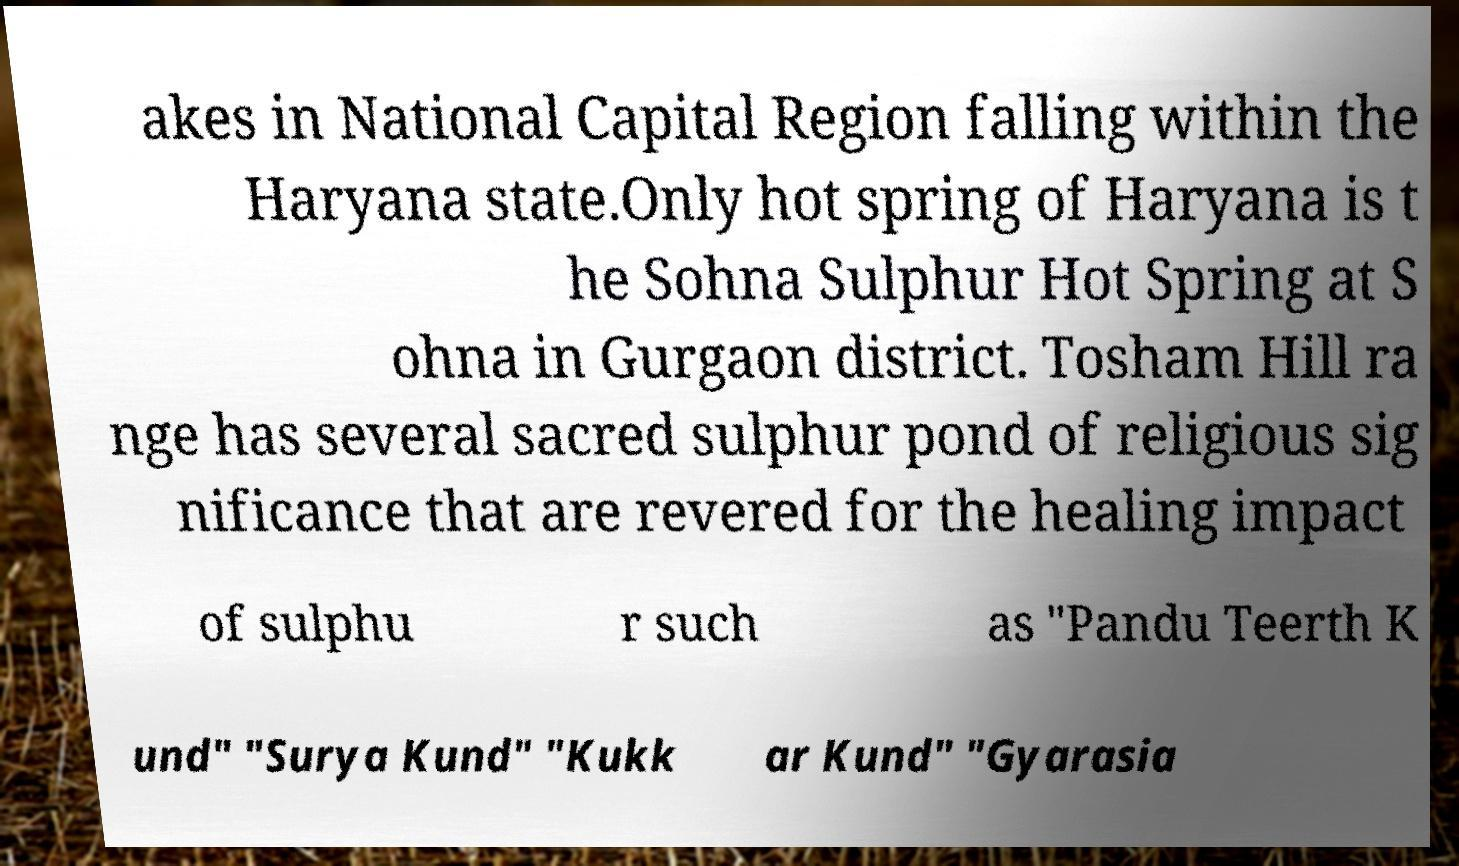For documentation purposes, I need the text within this image transcribed. Could you provide that? akes in National Capital Region falling within the Haryana state.Only hot spring of Haryana is t he Sohna Sulphur Hot Spring at S ohna in Gurgaon district. Tosham Hill ra nge has several sacred sulphur pond of religious sig nificance that are revered for the healing impact of sulphu r such as "Pandu Teerth K und" "Surya Kund" "Kukk ar Kund" "Gyarasia 